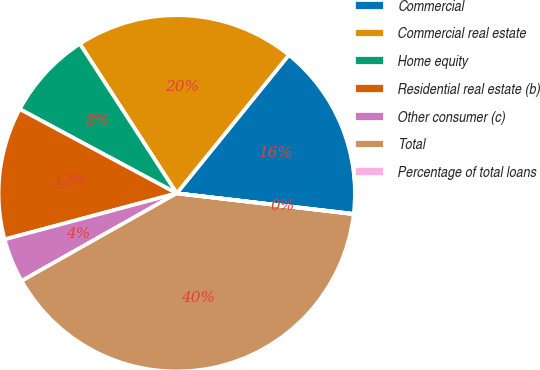Convert chart to OTSL. <chart><loc_0><loc_0><loc_500><loc_500><pie_chart><fcel>Commercial<fcel>Commercial real estate<fcel>Home equity<fcel>Residential real estate (b)<fcel>Other consumer (c)<fcel>Total<fcel>Percentage of total loans<nl><fcel>16.0%<fcel>19.99%<fcel>8.01%<fcel>12.0%<fcel>4.02%<fcel>39.95%<fcel>0.03%<nl></chart> 